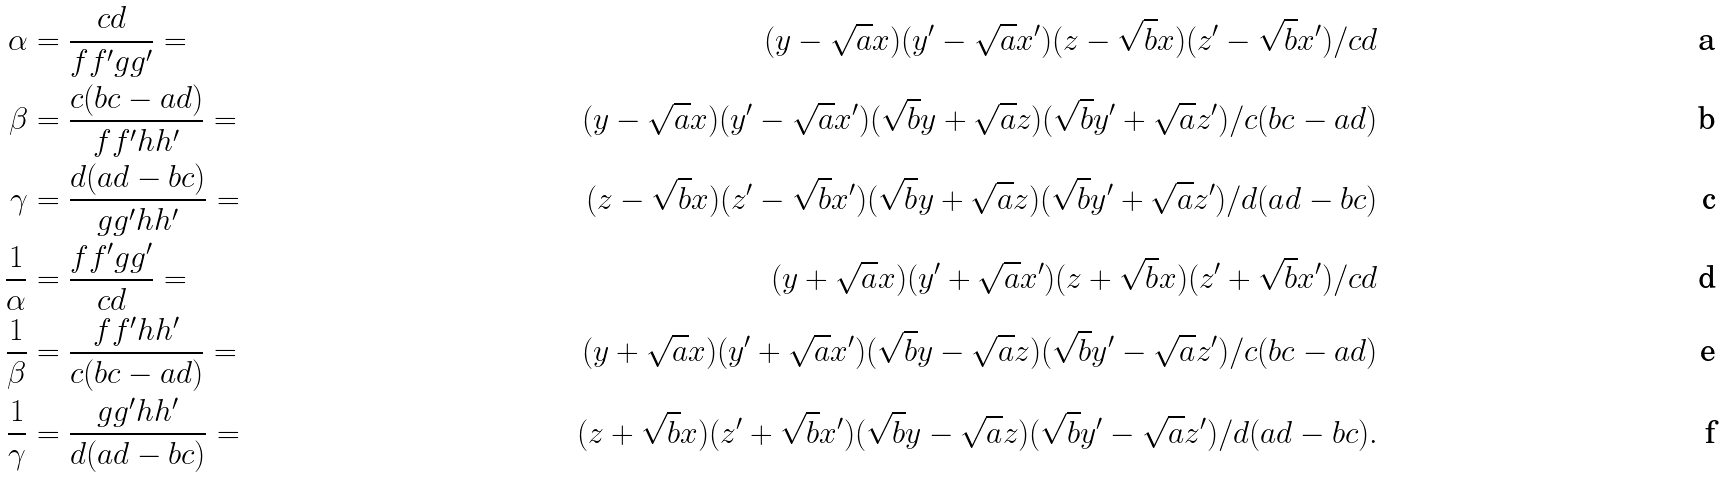<formula> <loc_0><loc_0><loc_500><loc_500>\alpha & = \frac { c d } { f f ^ { \prime } g g ^ { \prime } } = & ( y - \sqrt { a } x ) ( y ^ { \prime } - \sqrt { a } x ^ { \prime } ) ( z - \sqrt { b } x ) ( z ^ { \prime } - \sqrt { b } x ^ { \prime } ) / c d \\ \beta & = \frac { c ( b c - a d ) } { f f ^ { \prime } h h ^ { \prime } } = & ( y - \sqrt { a } x ) ( y ^ { \prime } - \sqrt { a } x ^ { \prime } ) ( \sqrt { b } y + \sqrt { a } z ) ( \sqrt { b } y ^ { \prime } + \sqrt { a } z ^ { \prime } ) / c ( b c - a d ) \\ \gamma & = \frac { d ( a d - b c ) } { g g ^ { \prime } h h ^ { \prime } } = & ( z - \sqrt { b } x ) ( z ^ { \prime } - \sqrt { b } x ^ { \prime } ) ( \sqrt { b } y + \sqrt { a } z ) ( \sqrt { b } y ^ { \prime } + \sqrt { a } z ^ { \prime } ) / d ( a d - b c ) \\ \frac { 1 } { \alpha } & = \frac { f f ^ { \prime } g g ^ { \prime } } { c d } = & ( y + \sqrt { a } x ) ( y ^ { \prime } + \sqrt { a } x ^ { \prime } ) ( z + \sqrt { b } x ) ( z ^ { \prime } + \sqrt { b } x ^ { \prime } ) / c d \\ \frac { 1 } { \beta } & = \frac { f f ^ { \prime } h h ^ { \prime } } { c ( b c - a d ) } = & ( y + \sqrt { a } x ) ( y ^ { \prime } + \sqrt { a } x ^ { \prime } ) ( \sqrt { b } y - \sqrt { a } z ) ( \sqrt { b } y ^ { \prime } - \sqrt { a } z ^ { \prime } ) / c ( b c - a d ) \\ \frac { 1 } { \gamma } & = \frac { g g ^ { \prime } h h ^ { \prime } } { d ( a d - b c ) } = & ( z + \sqrt { b } x ) ( z ^ { \prime } + \sqrt { b } x ^ { \prime } ) ( \sqrt { b } y - \sqrt { a } z ) ( \sqrt { b } y ^ { \prime } - \sqrt { a } z ^ { \prime } ) / d ( a d - b c ) .</formula> 